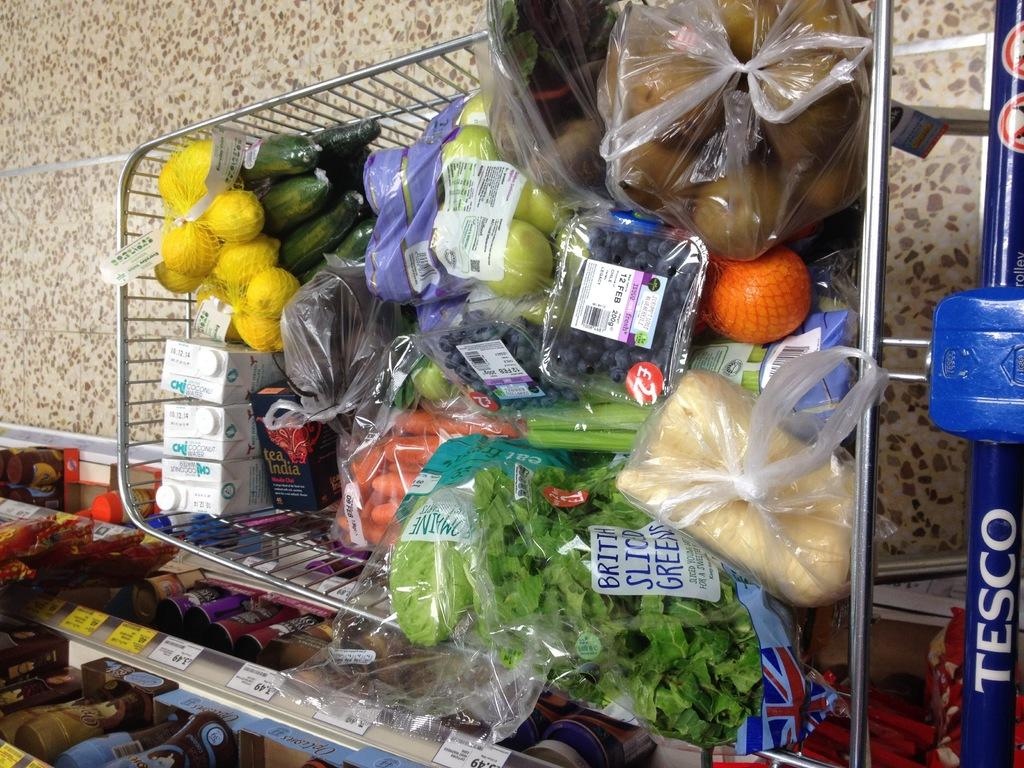What type of food can be seen in the trolley in the image? There are vegetables in the trolley. What else can be found in the trolley besides vegetables? There are other objects in the trolley. Where is the trolley located in the image? The trolley is on the floor. What can be seen in the racks in the image? There are bottles and other objects in the racks. How many balls are visible in the image? There are no balls present in the image. What type of unit is being used to measure the vegetables in the image? There is no unit of measurement visible in the image. 